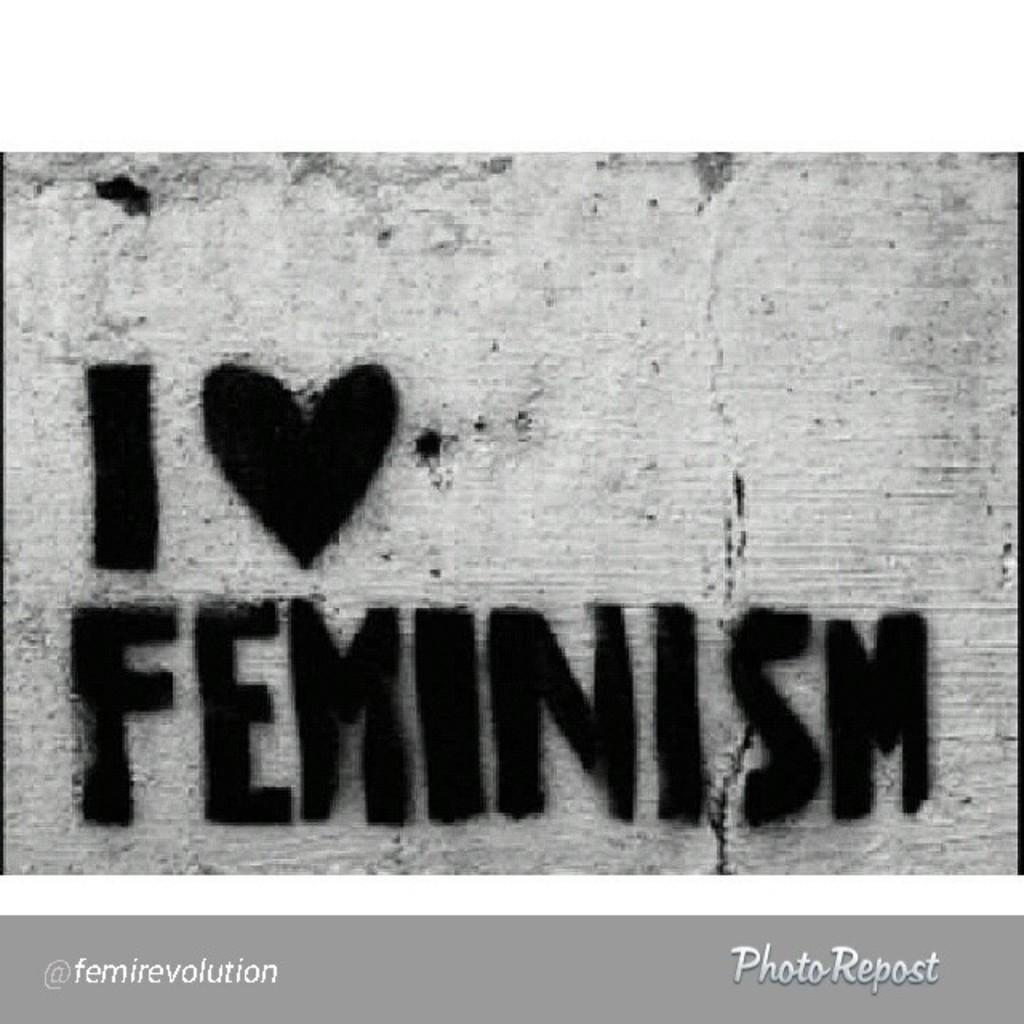<image>
Summarize the visual content of the image. "I Love Feminism" has been written on a concrete wall 